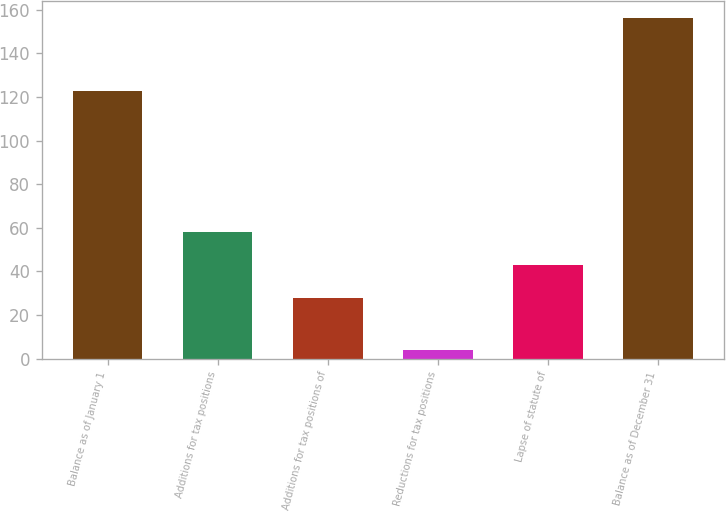Convert chart to OTSL. <chart><loc_0><loc_0><loc_500><loc_500><bar_chart><fcel>Balance as of January 1<fcel>Additions for tax positions<fcel>Additions for tax positions of<fcel>Reductions for tax positions<fcel>Lapse of statute of<fcel>Balance as of December 31<nl><fcel>122.7<fcel>58.12<fcel>27.7<fcel>4<fcel>42.91<fcel>156.1<nl></chart> 